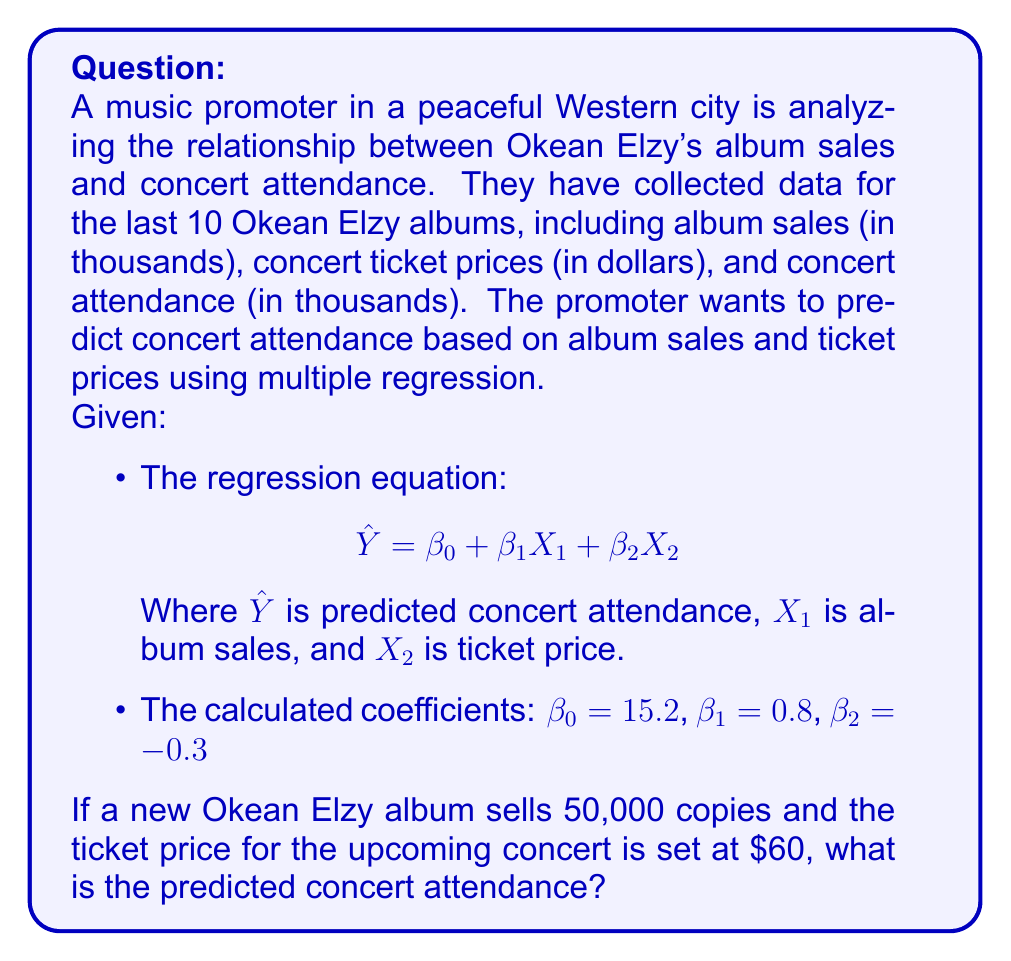Solve this math problem. To solve this problem, we'll follow these steps:

1. Identify the given information:
   - Regression equation: $$\hat{Y} = \beta_0 + \beta_1X_1 + \beta_2X_2$$
   - Coefficients: $\beta_0 = 15.2$, $\beta_1 = 0.8$, $\beta_2 = -0.3$
   - Album sales ($X_1$) = 50 (in thousands)
   - Ticket price ($X_2$) = $60

2. Substitute the values into the regression equation:
   $$\hat{Y} = 15.2 + 0.8X_1 + (-0.3)X_2$$
   $$\hat{Y} = 15.2 + 0.8(50) + (-0.3)(60)$$

3. Calculate each term:
   - $15.2$ (constant term)
   - $0.8 * 50 = 40$ (album sales term)
   - $-0.3 * 60 = -18$ (ticket price term)

4. Sum up all terms:
   $$\hat{Y} = 15.2 + 40 + (-18) = 37.2$$

5. Interpret the result:
   The predicted concert attendance is 37.2 thousand, or 37,200 people.
Answer: 37,200 people 